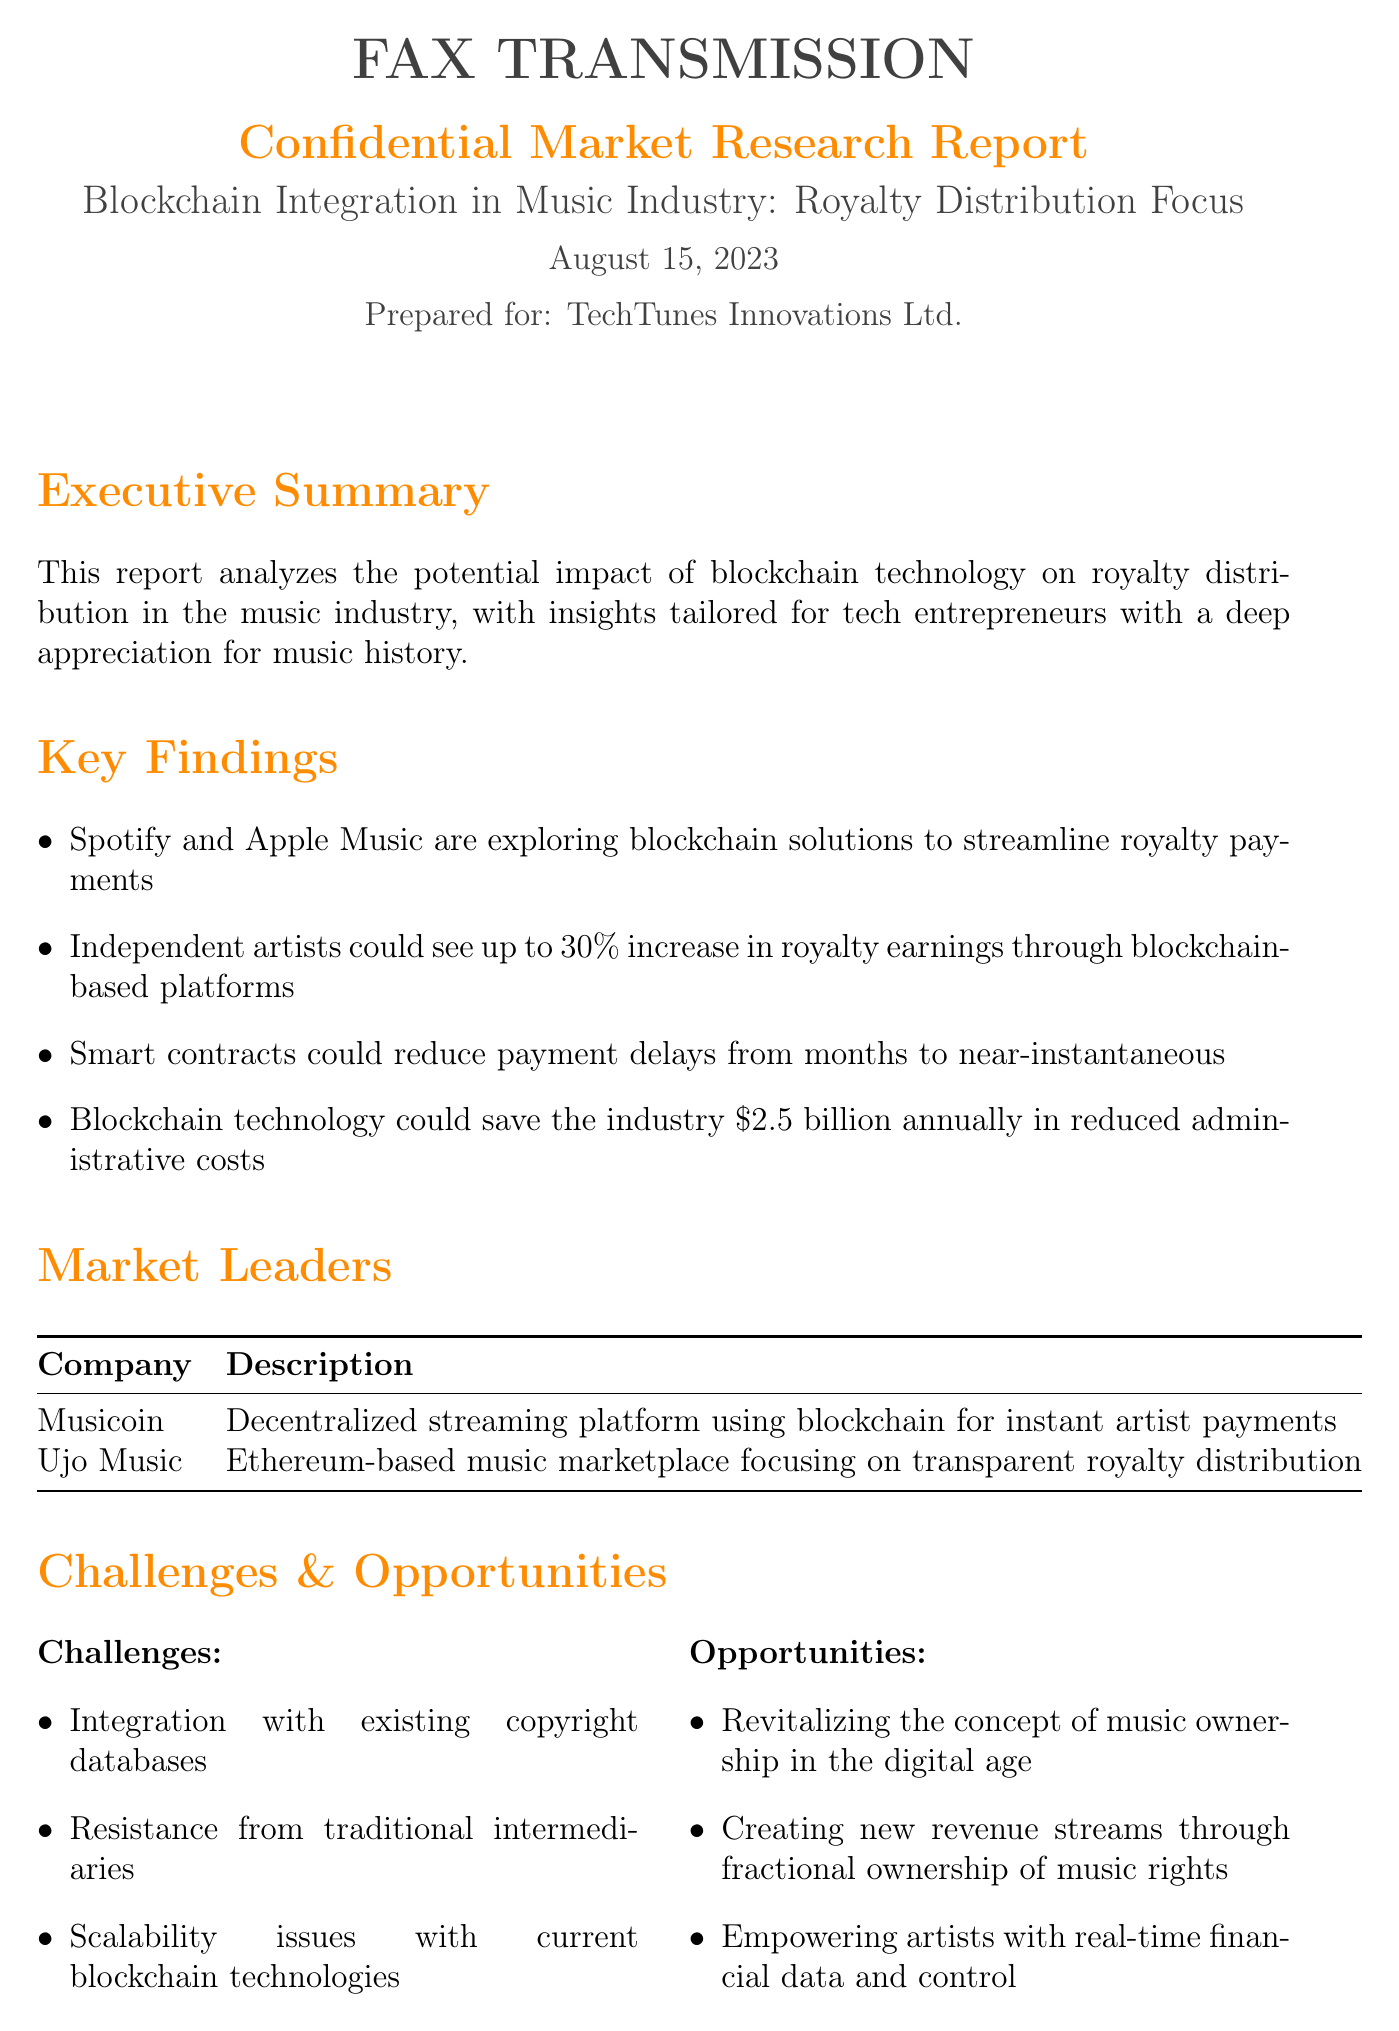What is the date of the report? The report is dated August 15, 2023.
Answer: August 15, 2023 What percentage increase in royalty earnings could independent artists see? The report states that independent artists could see up to a 30% increase in royalty earnings.
Answer: 30% Which two companies are identified as market leaders? The market leaders listed are Musicoin and Ujo Music.
Answer: Musicoin, Ujo Music What is the estimated annual savings for the industry through blockchain technology? The potential savings for the industry is estimated at $2.5 billion annually.
Answer: $2.5 billion What is one major challenge mentioned in the report? One challenge mentioned is the integration with existing copyright databases.
Answer: Integration with existing copyright databases Which opportunity involves revitalizing music ownership? The opportunity related to revitalizing music ownership in the digital age is highlighted in the report.
Answer: Revitalizing the concept of music ownership in the digital age What payment method could reduce delays to near-instantaneous? Smart contracts are identified as the payment method that could reduce delays significantly.
Answer: Smart contracts What does the report aim to empower artists with? The report aims to empower artists with real-time financial data and control.
Answer: Real-time financial data and control 